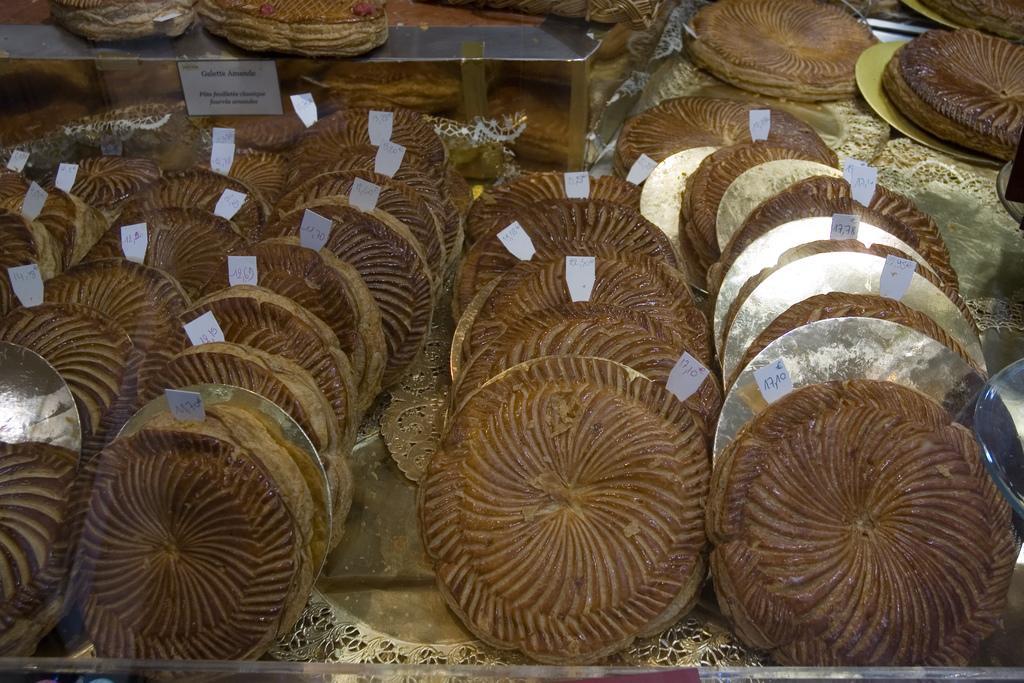How would you summarize this image in a sentence or two? In this picture we can see food items with price tags on it and these all are placed on trays. 